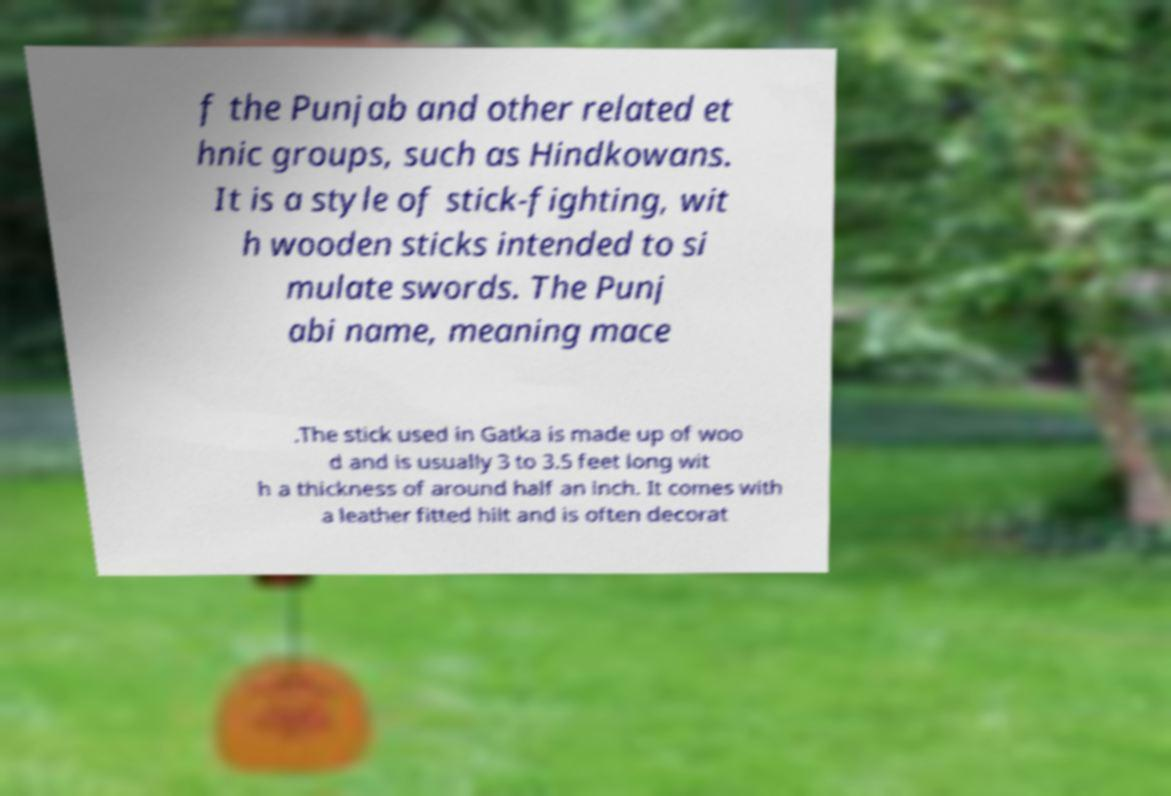Please identify and transcribe the text found in this image. f the Punjab and other related et hnic groups, such as Hindkowans. It is a style of stick-fighting, wit h wooden sticks intended to si mulate swords. The Punj abi name, meaning mace .The stick used in Gatka is made up of woo d and is usually 3 to 3.5 feet long wit h a thickness of around half an inch. It comes with a leather fitted hilt and is often decorat 